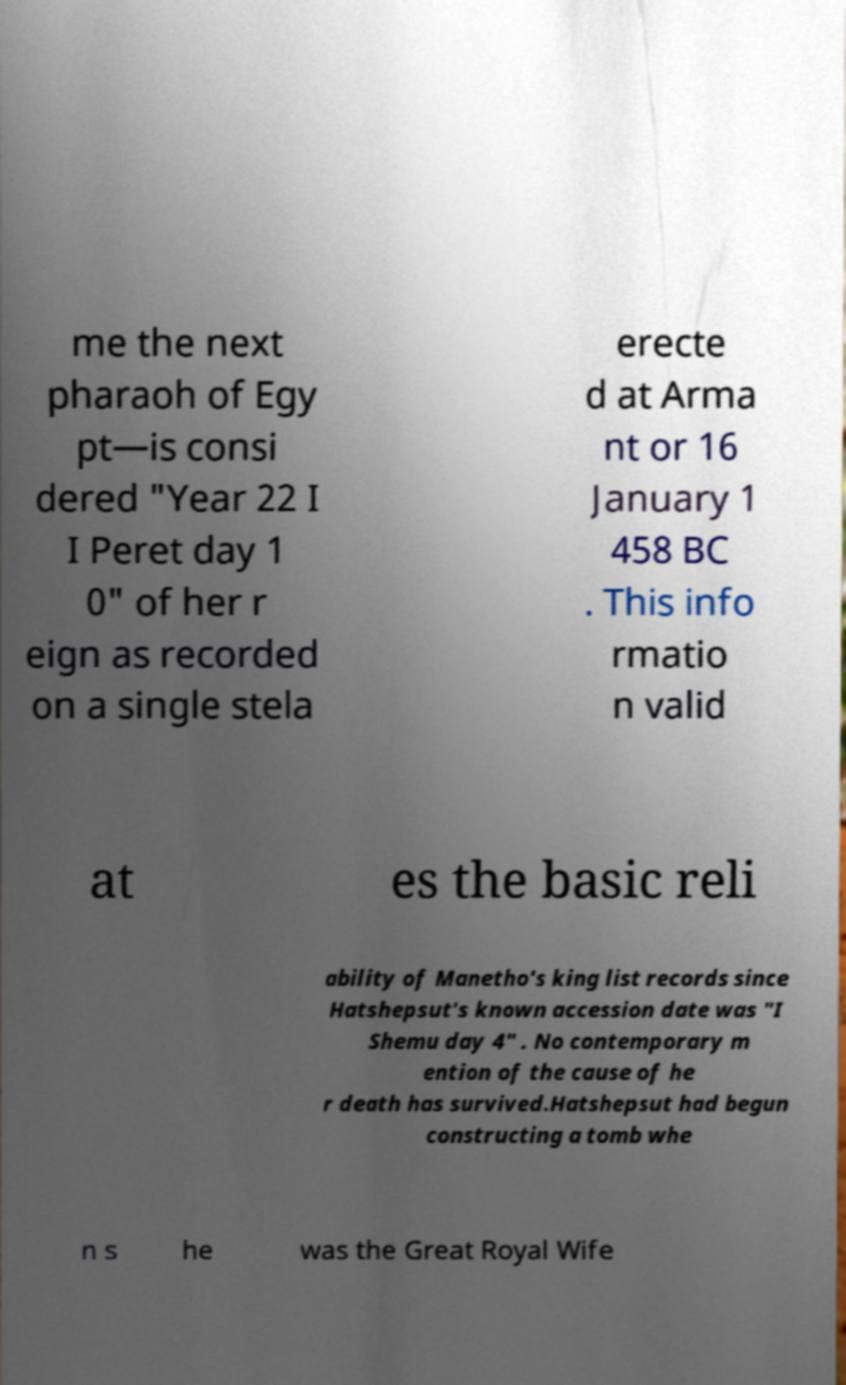Please read and relay the text visible in this image. What does it say? me the next pharaoh of Egy pt—is consi dered "Year 22 I I Peret day 1 0" of her r eign as recorded on a single stela erecte d at Arma nt or 16 January 1 458 BC . This info rmatio n valid at es the basic reli ability of Manetho's king list records since Hatshepsut's known accession date was "I Shemu day 4" . No contemporary m ention of the cause of he r death has survived.Hatshepsut had begun constructing a tomb whe n s he was the Great Royal Wife 